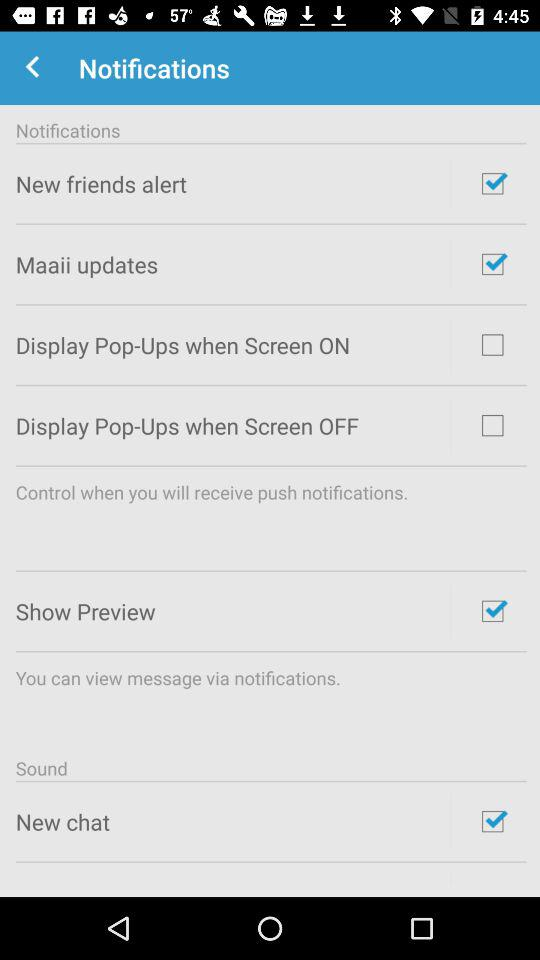How many items have a checkbox that is unchecked?
Answer the question using a single word or phrase. 2 